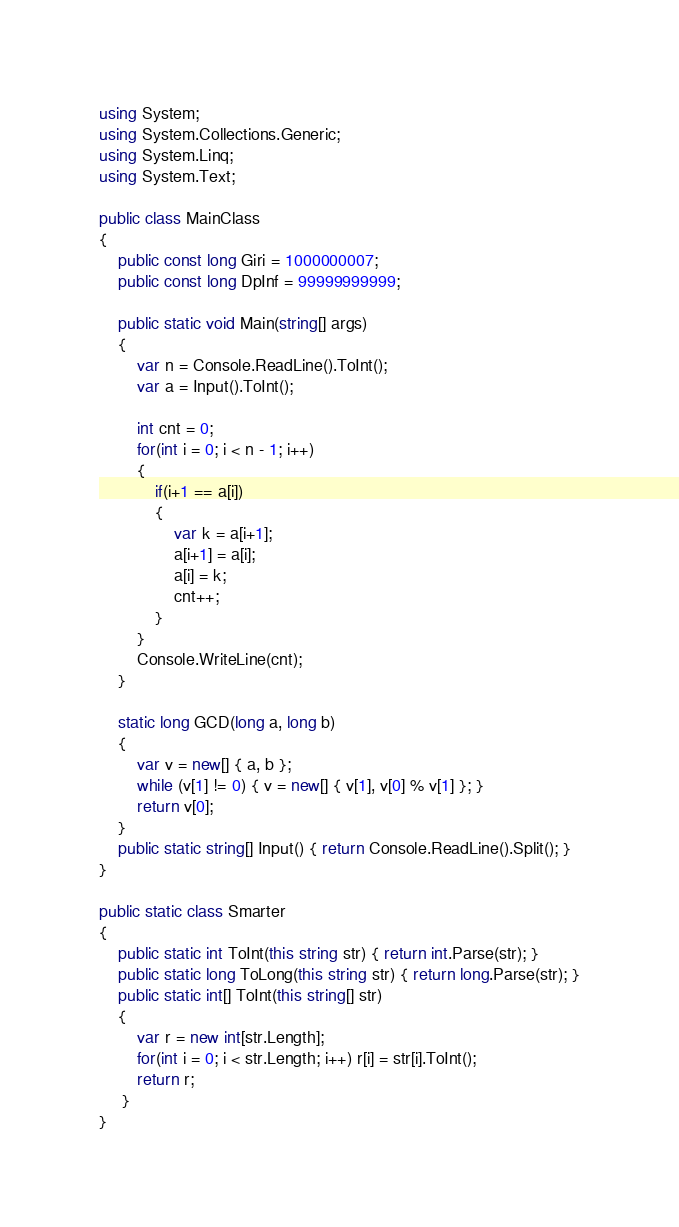<code> <loc_0><loc_0><loc_500><loc_500><_C#_>using System;
using System.Collections.Generic;
using System.Linq;
using System.Text;

public class MainClass
{
	public const long Giri = 1000000007;
	public const long DpInf = 99999999999;
	
	public static void Main(string[] args)
	{
		var n = Console.ReadLine().ToInt();
		var a = Input().ToInt();
		
		int cnt = 0;
		for(int i = 0; i < n - 1; i++)
		{
			if(i+1 == a[i])
			{
				var k = a[i+1];
				a[i+1] = a[i];
				a[i] = k;
				cnt++;
			}
		}
		Console.WriteLine(cnt);
	}
	
	static long GCD(long a, long b)
	{
		var v = new[] { a, b };
		while (v[1] != 0) { v = new[] { v[1], v[0] % v[1] }; }
		return v[0];
	}
	public static string[] Input() { return Console.ReadLine().Split(); }
}

public static class Smarter
{
	public static int ToInt(this string str) { return int.Parse(str); }
	public static long ToLong(this string str) { return long.Parse(str); }
	public static int[] ToInt(this string[] str)
	{
		var r = new int[str.Length];
		for(int i = 0; i < str.Length; i++) r[i] = str[i].ToInt();
		return r;
	 }
}
</code> 